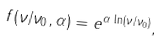<formula> <loc_0><loc_0><loc_500><loc_500>f ( \nu / \nu _ { 0 } , \alpha ) = e ^ { \alpha \, \ln ( \nu / \nu _ { 0 } ) } ,</formula> 